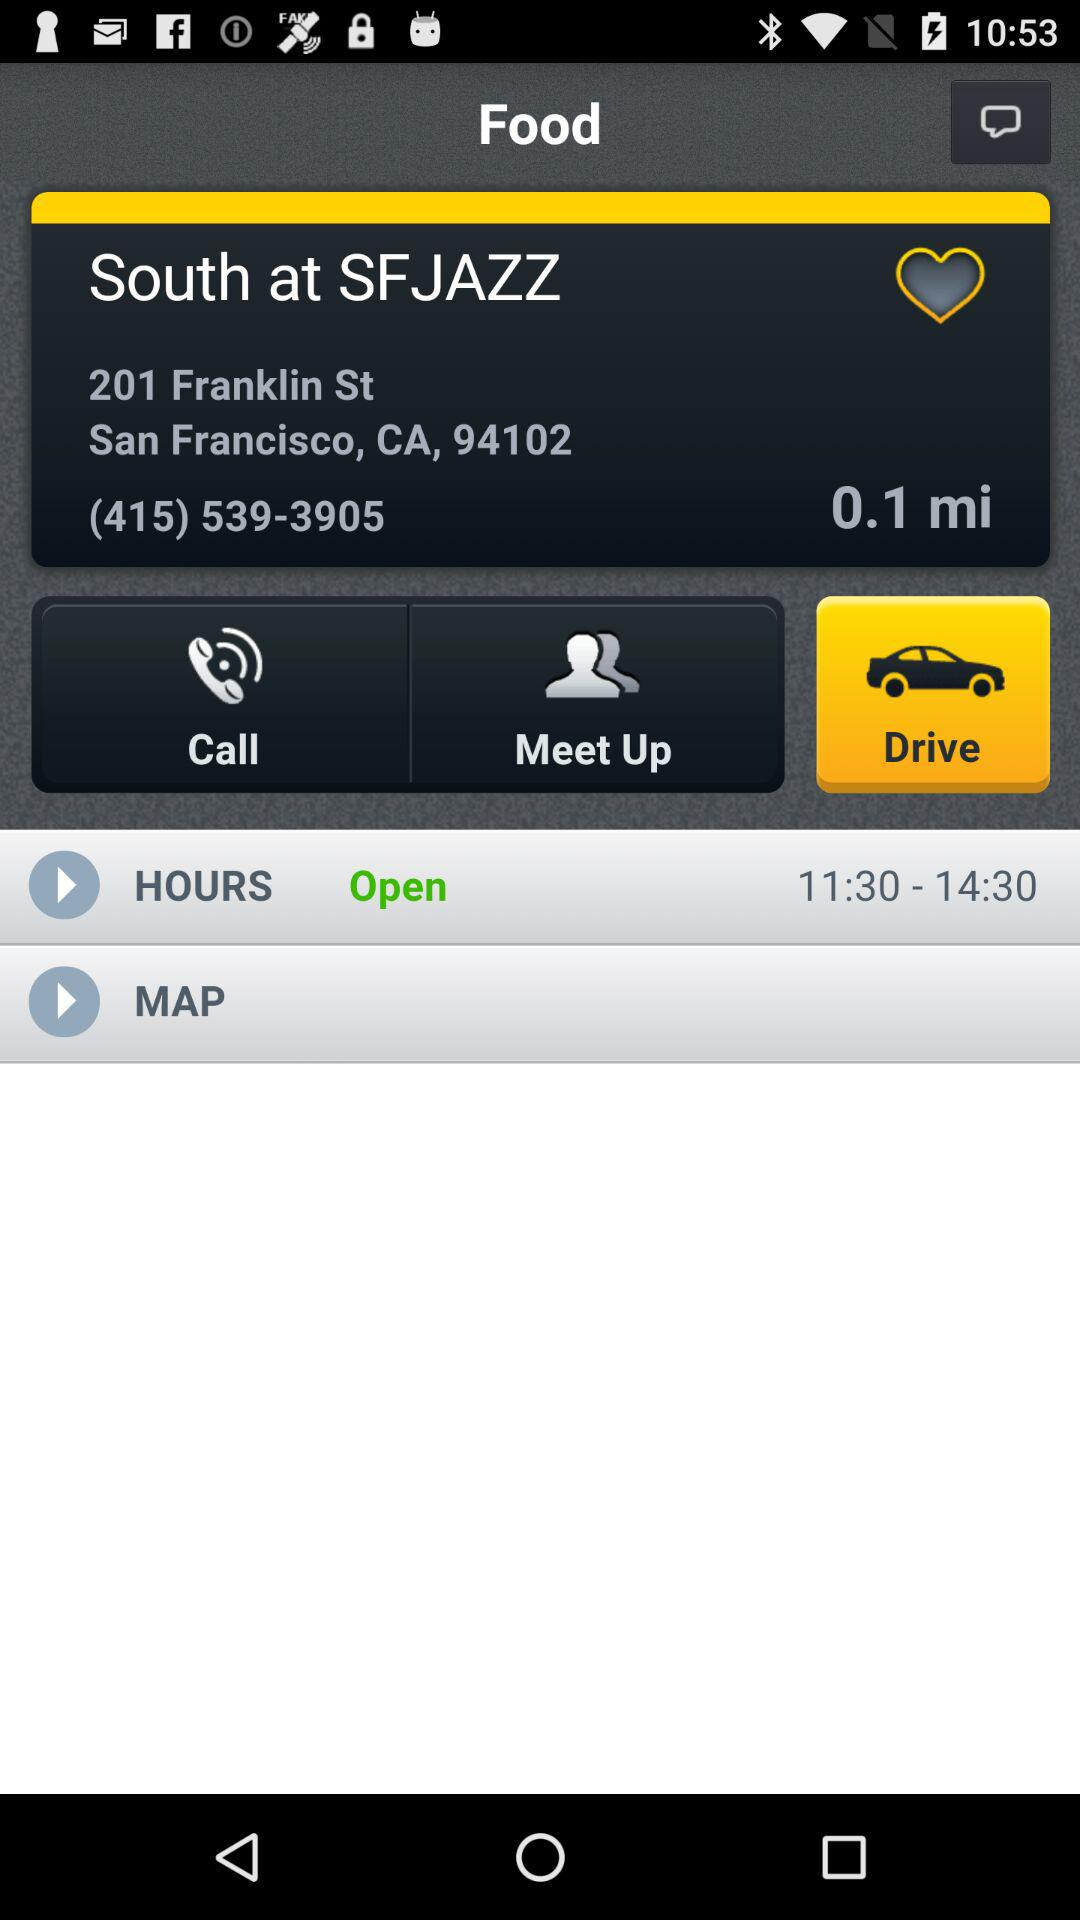What is the distance from South at SFJAZZ to the user?
Answer the question using a single word or phrase. 0.1 mi 